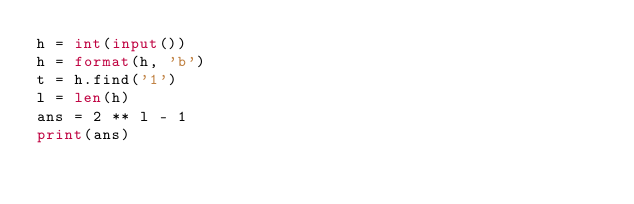Convert code to text. <code><loc_0><loc_0><loc_500><loc_500><_Python_>h = int(input())
h = format(h, 'b')
t = h.find('1')
l = len(h)
ans = 2 ** l - 1
print(ans)</code> 